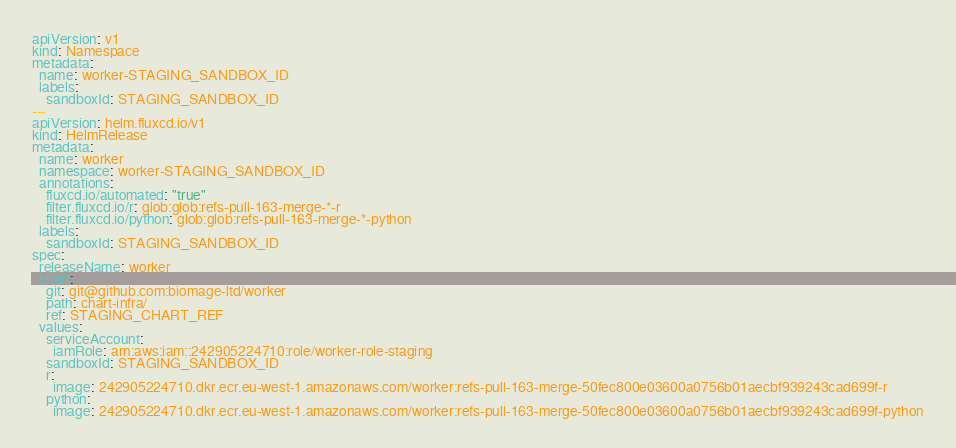Convert code to text. <code><loc_0><loc_0><loc_500><loc_500><_YAML_>apiVersion: v1
kind: Namespace
metadata:
  name: worker-STAGING_SANDBOX_ID
  labels:
    sandboxId: STAGING_SANDBOX_ID
---
apiVersion: helm.fluxcd.io/v1
kind: HelmRelease
metadata:
  name: worker
  namespace: worker-STAGING_SANDBOX_ID
  annotations:
    fluxcd.io/automated: "true"
    filter.fluxcd.io/r: glob:glob:refs-pull-163-merge-*-r
    filter.fluxcd.io/python: glob:glob:refs-pull-163-merge-*-python
  labels:
    sandboxId: STAGING_SANDBOX_ID
spec:
  releaseName: worker
  chart:
    git: git@github.com:biomage-ltd/worker
    path: chart-infra/
    ref: STAGING_CHART_REF
  values:
    serviceAccount:
      iamRole: arn:aws:iam::242905224710:role/worker-role-staging
    sandboxId: STAGING_SANDBOX_ID
    r:
      image: 242905224710.dkr.ecr.eu-west-1.amazonaws.com/worker:refs-pull-163-merge-50fec800e03600a0756b01aecbf939243cad699f-r
    python:
      image: 242905224710.dkr.ecr.eu-west-1.amazonaws.com/worker:refs-pull-163-merge-50fec800e03600a0756b01aecbf939243cad699f-python
</code> 